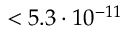Convert formula to latex. <formula><loc_0><loc_0><loc_500><loc_500>< 5 . 3 \cdot 1 0 ^ { - 1 1 }</formula> 